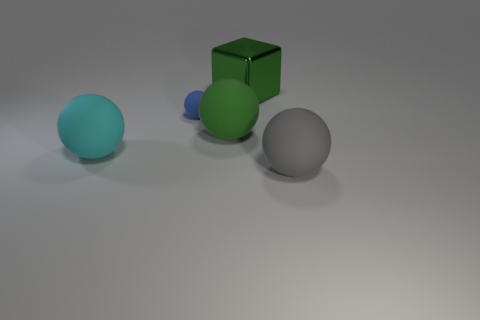Add 5 tiny yellow metal objects. How many objects exist? 10 Subtract all blocks. How many objects are left? 4 Subtract 0 green cylinders. How many objects are left? 5 Subtract all big shiny cylinders. Subtract all cyan balls. How many objects are left? 4 Add 2 blue objects. How many blue objects are left? 3 Add 2 big cyan shiny things. How many big cyan shiny things exist? 2 